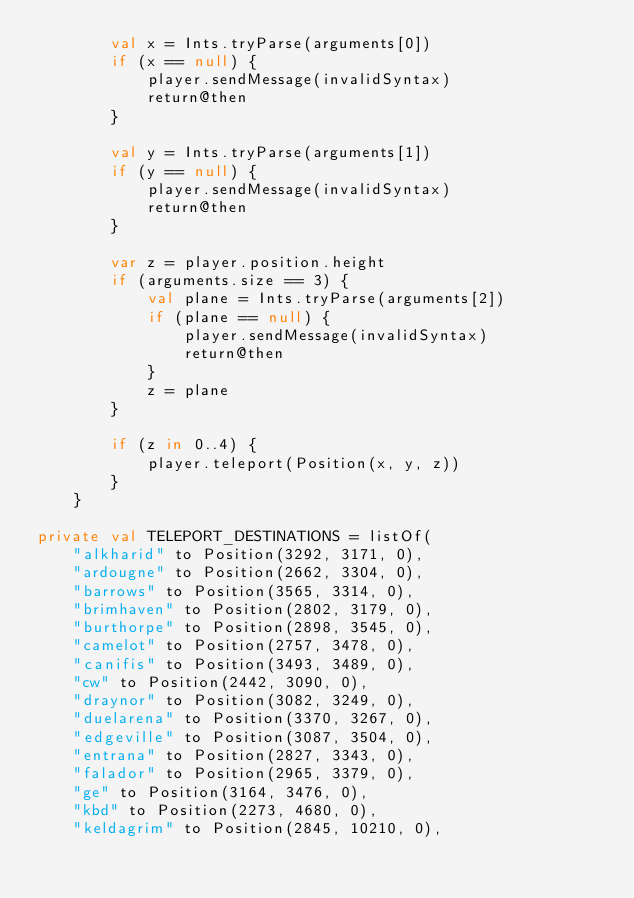<code> <loc_0><loc_0><loc_500><loc_500><_Kotlin_>        val x = Ints.tryParse(arguments[0])
        if (x == null) {
            player.sendMessage(invalidSyntax)
            return@then
        }

        val y = Ints.tryParse(arguments[1])
        if (y == null) {
            player.sendMessage(invalidSyntax)
            return@then
        }

        var z = player.position.height
        if (arguments.size == 3) {
            val plane = Ints.tryParse(arguments[2])
            if (plane == null) {
                player.sendMessage(invalidSyntax)
                return@then
            }
            z = plane
        }

        if (z in 0..4) {
            player.teleport(Position(x, y, z))
        }
    }

private val TELEPORT_DESTINATIONS = listOf(
    "alkharid" to Position(3292, 3171, 0),
    "ardougne" to Position(2662, 3304, 0),
    "barrows" to Position(3565, 3314, 0),
    "brimhaven" to Position(2802, 3179, 0),
    "burthorpe" to Position(2898, 3545, 0),
    "camelot" to Position(2757, 3478, 0),
    "canifis" to Position(3493, 3489, 0),
    "cw" to Position(2442, 3090, 0),
    "draynor" to Position(3082, 3249, 0),
    "duelarena" to Position(3370, 3267, 0),
    "edgeville" to Position(3087, 3504, 0),
    "entrana" to Position(2827, 3343, 0),
    "falador" to Position(2965, 3379, 0),
    "ge" to Position(3164, 3476, 0),
    "kbd" to Position(2273, 4680, 0),
    "keldagrim" to Position(2845, 10210, 0),</code> 